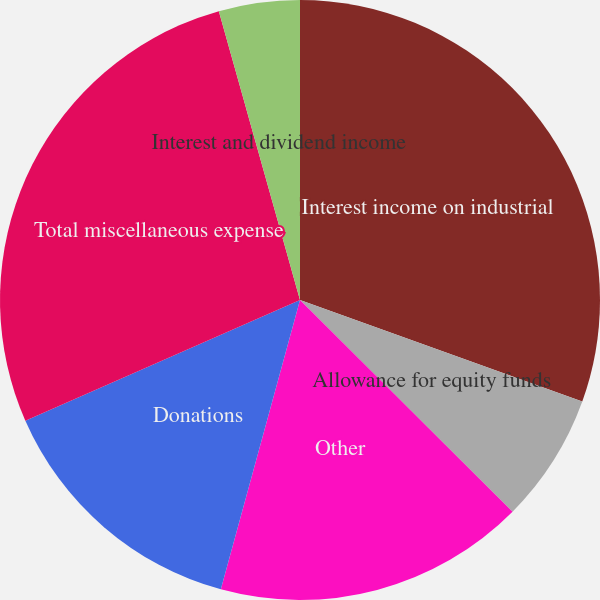Convert chart. <chart><loc_0><loc_0><loc_500><loc_500><pie_chart><fcel>Interest income on industrial<fcel>Allowance for equity funds<fcel>Other<fcel>Donations<fcel>Total miscellaneous expense<fcel>Interest and dividend income<nl><fcel>30.5%<fcel>6.97%<fcel>16.78%<fcel>14.16%<fcel>27.23%<fcel>4.36%<nl></chart> 